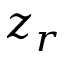<formula> <loc_0><loc_0><loc_500><loc_500>z _ { r }</formula> 